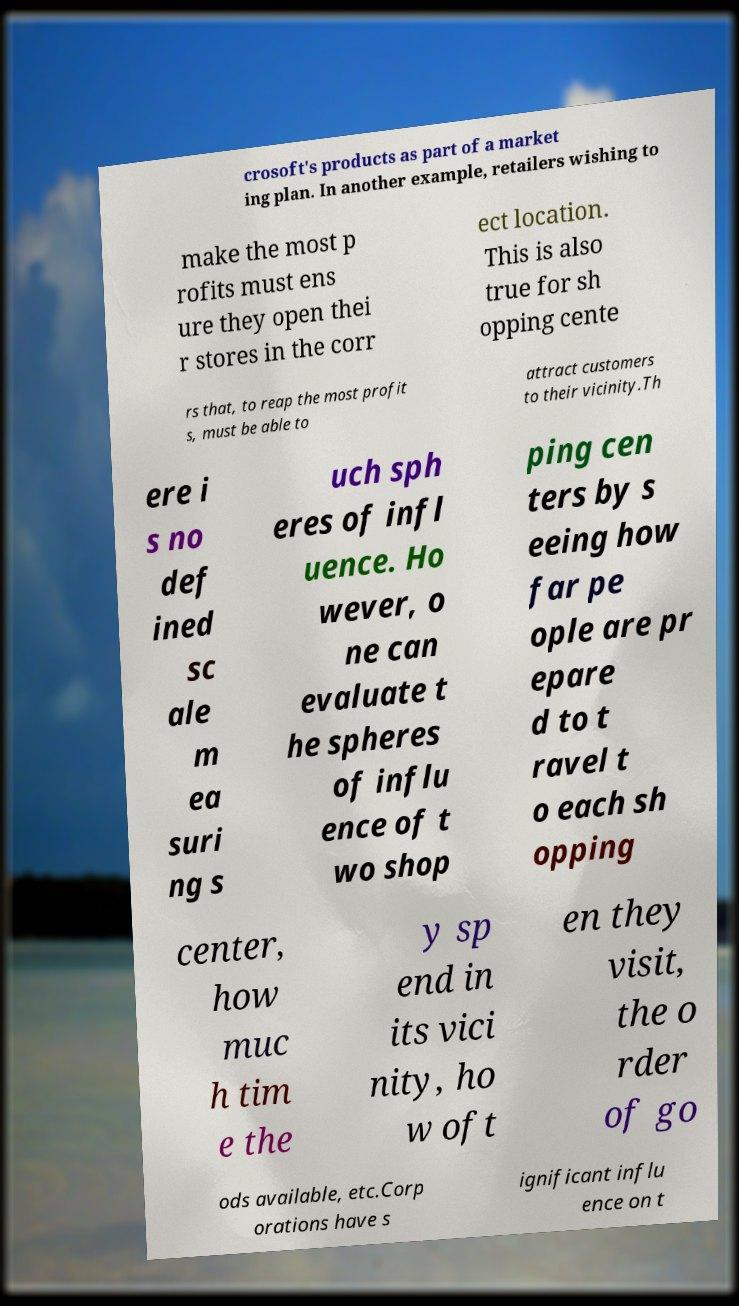Could you extract and type out the text from this image? crosoft's products as part of a market ing plan. In another example, retailers wishing to make the most p rofits must ens ure they open thei r stores in the corr ect location. This is also true for sh opping cente rs that, to reap the most profit s, must be able to attract customers to their vicinity.Th ere i s no def ined sc ale m ea suri ng s uch sph eres of infl uence. Ho wever, o ne can evaluate t he spheres of influ ence of t wo shop ping cen ters by s eeing how far pe ople are pr epare d to t ravel t o each sh opping center, how muc h tim e the y sp end in its vici nity, ho w oft en they visit, the o rder of go ods available, etc.Corp orations have s ignificant influ ence on t 